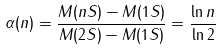<formula> <loc_0><loc_0><loc_500><loc_500>\alpha ( n ) = \frac { M ( n S ) - M ( 1 S ) } { M ( 2 S ) - M ( 1 S ) } = \frac { \ln n } { \ln 2 }</formula> 